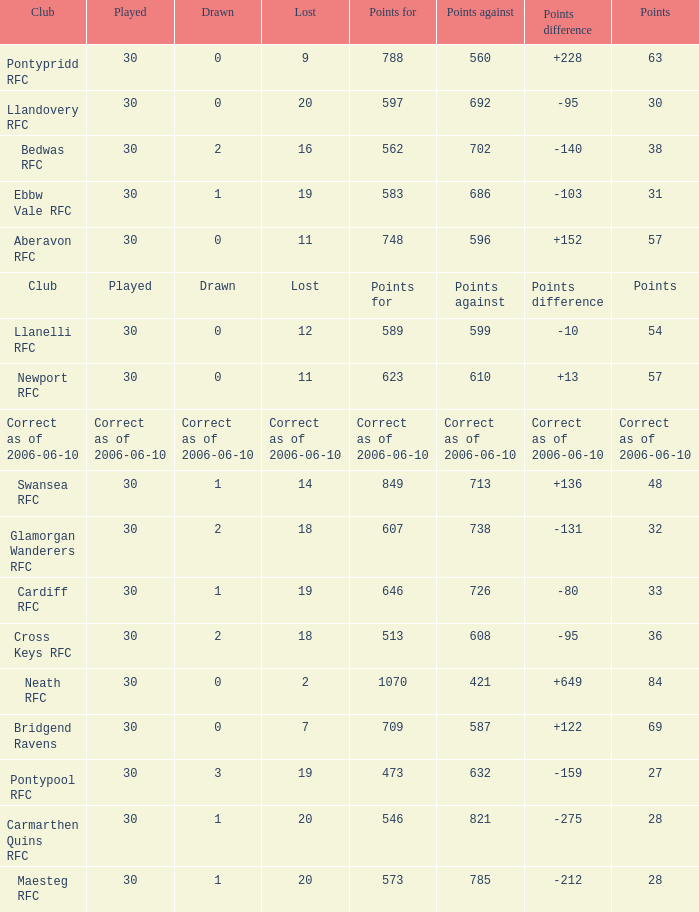What is Drawn, when Points Against is "686"? 1.0. 